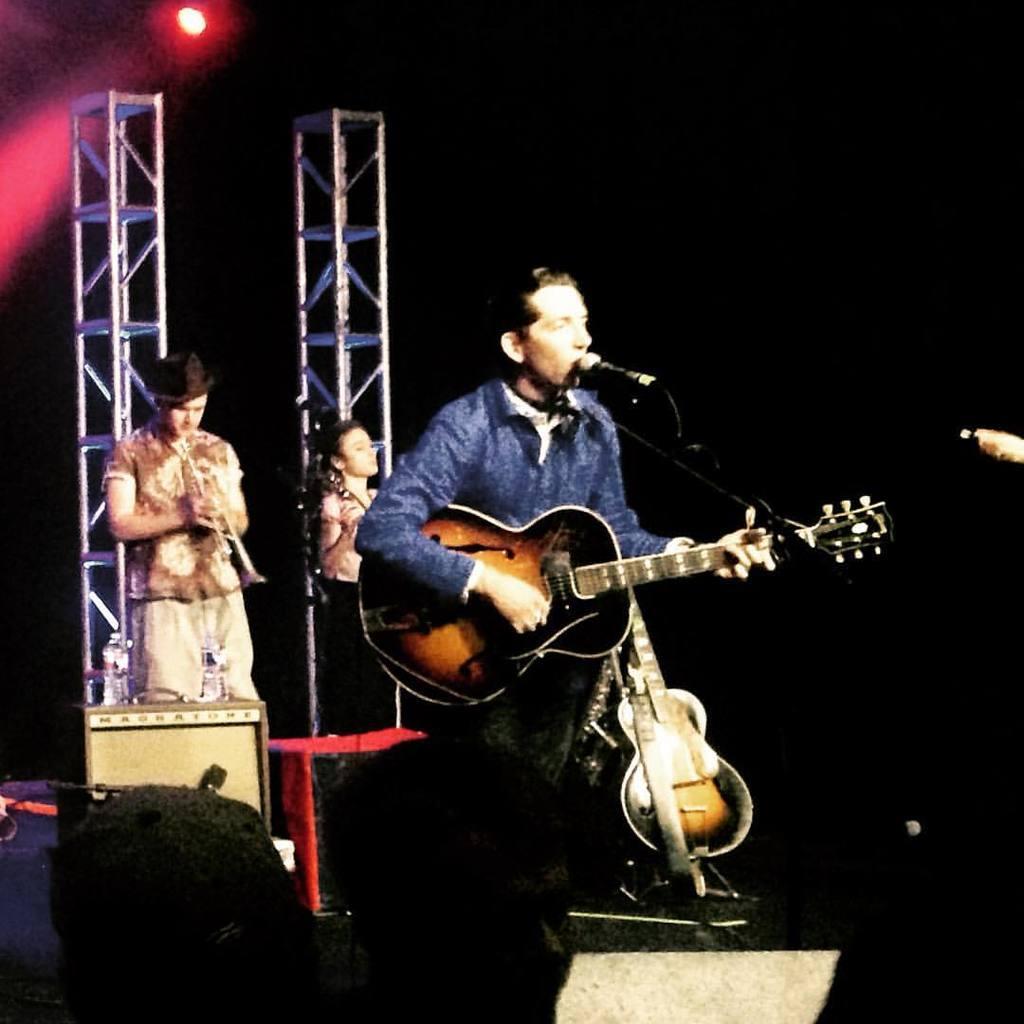Could you give a brief overview of what you see in this image? In the image there are three people who are playing their musical instrument. In middle there is a man who is playing his guitar in front of a microphone. On left side there is man who is playing his saxophone and there is table on left side on table we can see two water bottles. On right side we can see a woman with her musical instrument on top we can see light. 